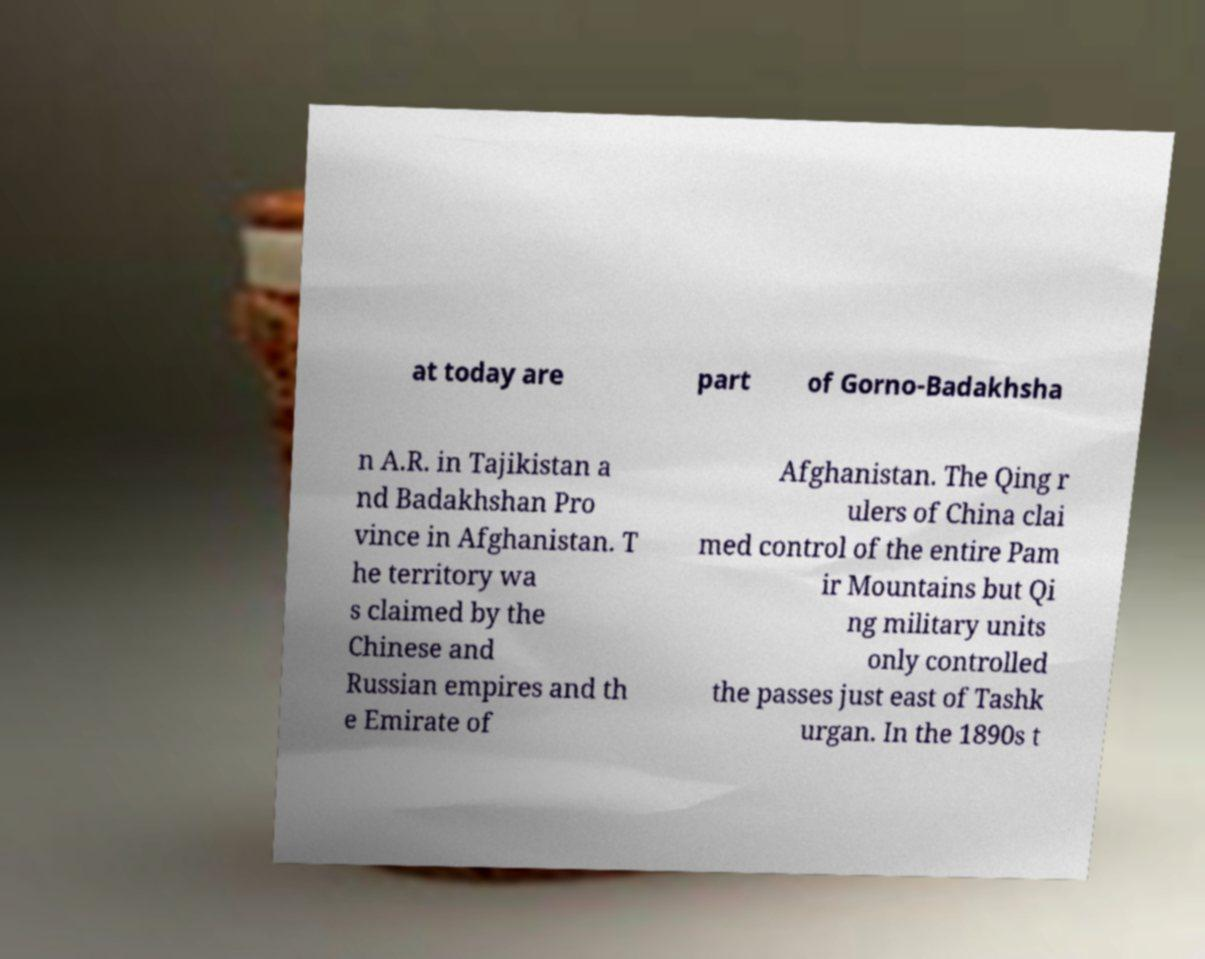Could you assist in decoding the text presented in this image and type it out clearly? at today are part of Gorno-Badakhsha n A.R. in Tajikistan a nd Badakhshan Pro vince in Afghanistan. T he territory wa s claimed by the Chinese and Russian empires and th e Emirate of Afghanistan. The Qing r ulers of China clai med control of the entire Pam ir Mountains but Qi ng military units only controlled the passes just east of Tashk urgan. In the 1890s t 